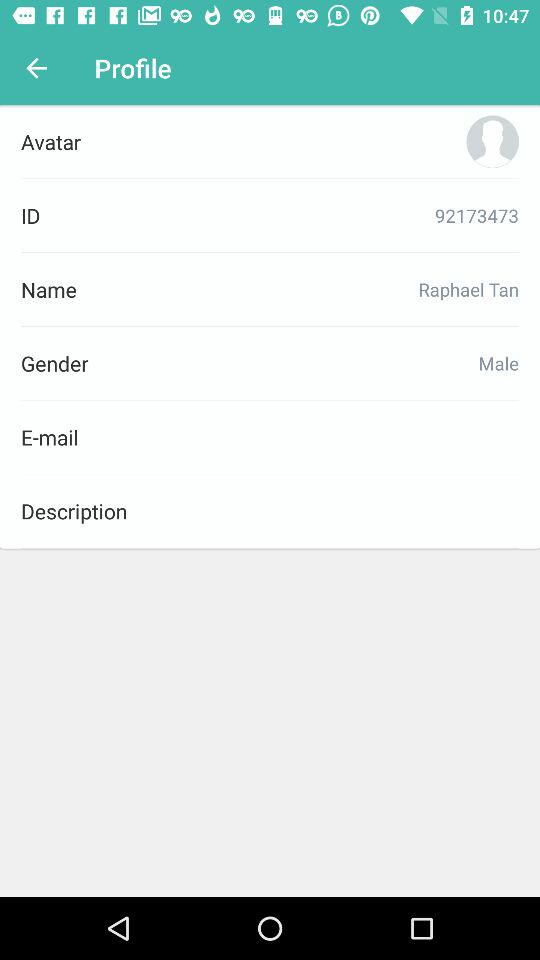What is the user name? The user name is Avatar. 